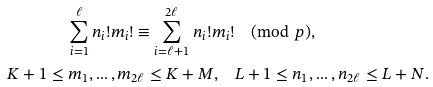<formula> <loc_0><loc_0><loc_500><loc_500>\sum _ { i = 1 } ^ { \ell } n _ { i } ! m _ { i } ! \equiv \sum _ { i = \ell + 1 } ^ { 2 \ell } n _ { i } ! m _ { i } ! & \pmod { p } , \\ K + 1 \leq m _ { 1 } , \dots , m _ { 2 \ell } \leq K + M , \quad & L + 1 \leq n _ { 1 } , \dots , n _ { 2 \ell } \leq L + N .</formula> 